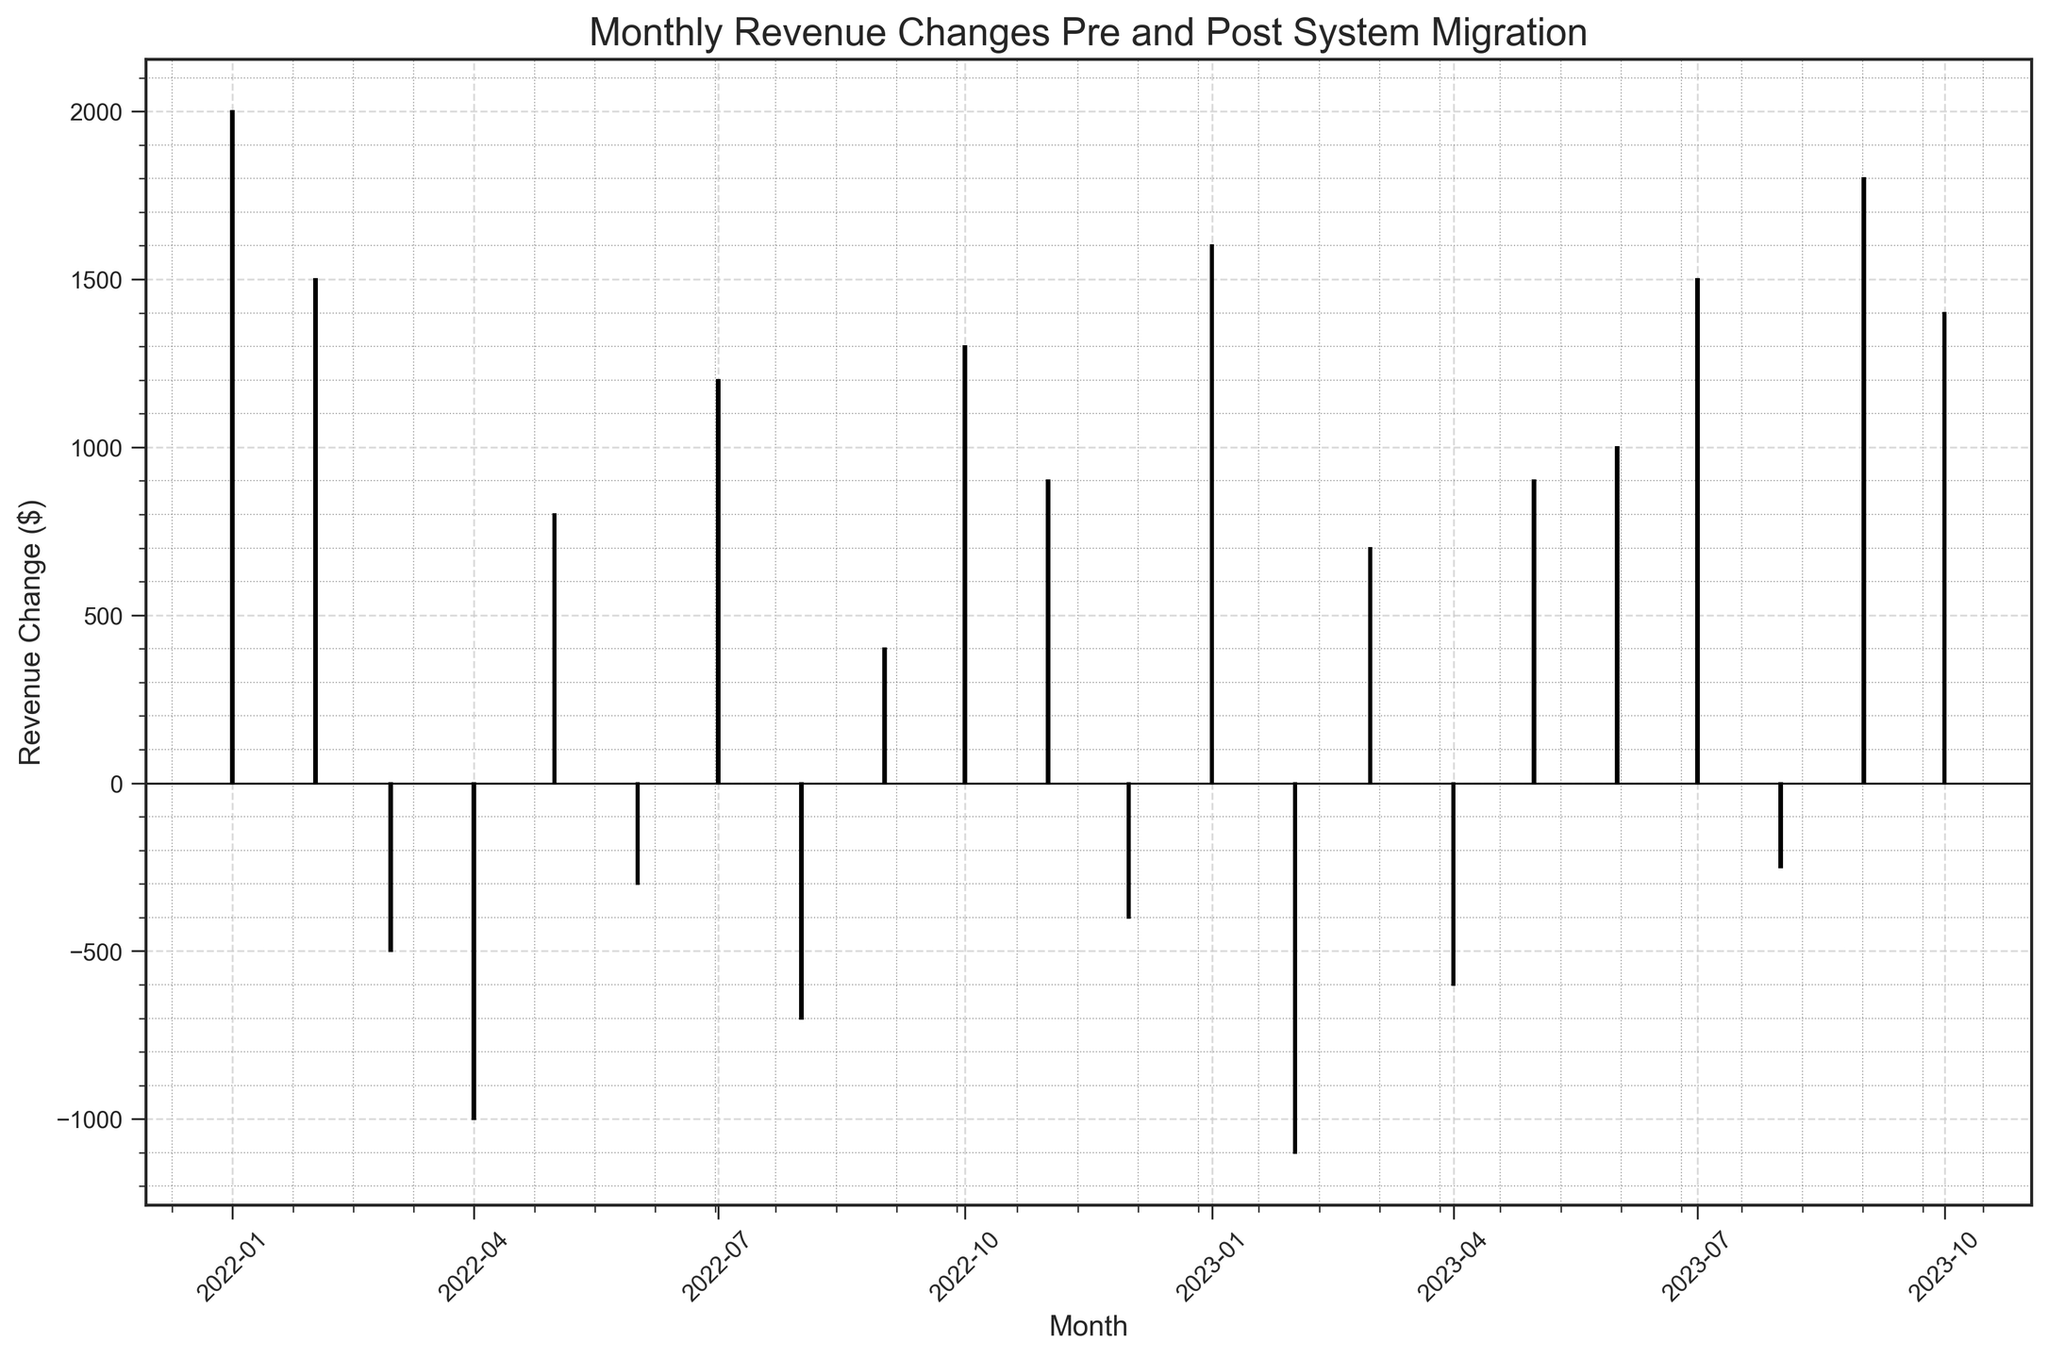How many months had negative revenue changes? To answer this, count only the red bars in the figure since negative changes are color-coded as red. There are 10 red bars.
Answer: 10 What is the average revenue change over the entire period? Calculate the sum of all revenue changes and divide by the number of months. Sum: 2000 + 1500 - 500 - 1000 + 800 - 300 + 1200 - 700 + 400 + 1300 + 900 - 400 + 1600 - 1100 + 700 - 600 + 900 + 1000 + 1500 - 250 + 1800 + 1400 = 15850. Number of months: 22. Average = 15850 / 22 ≈ 720.45
Answer: 720.45 Which month had the highest revenue change, and what was the value? Inspect the figure for the tallest green bar. The tallest green bar represents the month with the highest revenue change, which is September 2023 with a value of 1800.
Answer: September 2023, 1800 Compare the total revenue change in 2022 with that in 2023 (up to October). Which year had a higher total revenue change? Sum the revenue changes for each year separately. For 2022: 2000 + 1500 - 500 - 1000 + 800 - 300 + 1200 - 700 + 400 + 1300 + 900 - 400 = 6300. For 2023: 1600 - 1100 + 700 - 600 + 900 + 1000 + 1500 - 250 + 1800 + 1400 = 9950. 2023 had a higher total revenue change.
Answer: 2023 Which month had the largest negative revenue change, and what was the value? Inspect the figure for the tallest red bar. The tallest red bar represents the month with the largest negative revenue change, which is February 2023 with a value of -1100.
Answer: February 2023, -1100 What is the overall trend in revenue changes after the system migration? Observe the bars from January 2023 onwards. Generally, the green bars are taller and more frequent compared to earlier months, indicating an overall positive trend after system migration.
Answer: Positive trend How does the revenue change in March 2022 compare to March 2023? March 2022 has a red bar at -500 while March 2023 has a green bar at 700. March 2023 has a higher revenue change compared to March 2022.
Answer: March 2023 is higher What's the average revenue change for the first six months of 2023? Calculate the sum of revenue changes for January to June 2023 and divide by 6. Sum: 1600 - 1100 + 700 - 600 + 900 + 1000 = 3500. Average = 3500 / 6 = 583.33
Answer: 583.33 